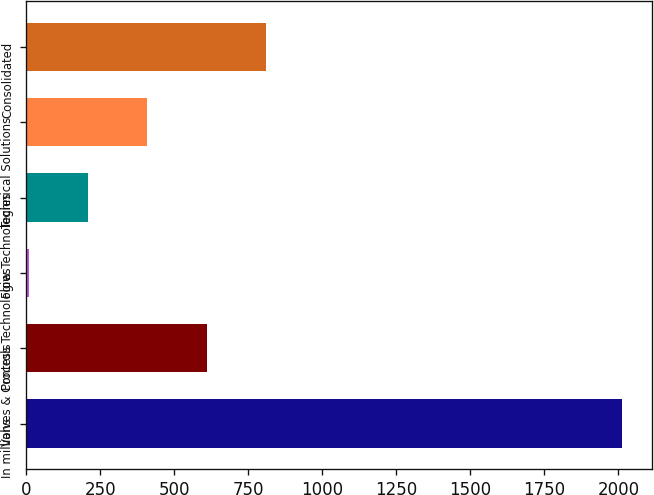Convert chart. <chart><loc_0><loc_0><loc_500><loc_500><bar_chart><fcel>In millions<fcel>Valves & Controls<fcel>Process Technologies<fcel>Flow Technologies<fcel>Technical Solutions<fcel>Consolidated<nl><fcel>2013<fcel>610.48<fcel>9.4<fcel>209.76<fcel>410.12<fcel>810.84<nl></chart> 